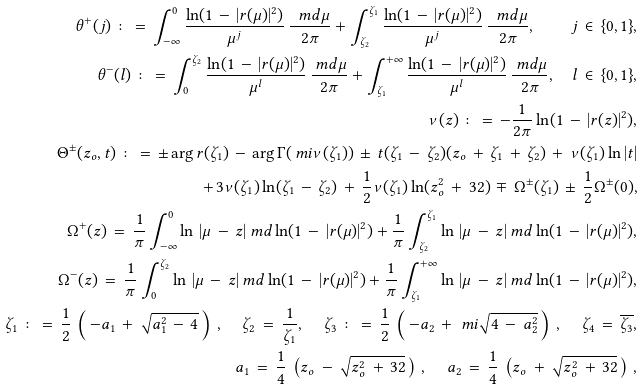Convert formula to latex. <formula><loc_0><loc_0><loc_500><loc_500>\theta ^ { + } ( j ) \, \colon = \, \int _ { - \infty } ^ { 0 } \frac { \ln ( 1 \, - \, | r ( \mu ) | ^ { 2 } ) } { \mu ^ { j } } \, \frac { \ m d \mu } { 2 \pi } + \int _ { \zeta _ { 2 } } ^ { \zeta _ { 1 } } \frac { \ln ( 1 \, - \, | r ( \mu ) | ^ { 2 } ) } { \mu ^ { j } } \, \frac { \ m d \mu } { 2 \pi } , \quad j \, \in \, \{ 0 , 1 \} , \\ \theta ^ { - } ( l ) \, \colon = \, \int _ { 0 } ^ { \zeta _ { 2 } } \frac { \ln ( 1 \, - \, | r ( \mu ) | ^ { 2 } ) } { \mu ^ { l } } \, \frac { \ m d \mu } { 2 \pi } + \int _ { \zeta _ { 1 } } ^ { + \infty } \frac { \ln ( 1 \, - \, | r ( \mu ) | ^ { 2 } ) } { \mu ^ { l } } \, \frac { \ m d \mu } { 2 \pi } , \quad l \, \in \, \{ 0 , 1 \} , \\ \nu ( z ) \, \colon = \, - \frac { 1 } { 2 \pi } \ln ( 1 \, - \, | r ( z ) | ^ { 2 } ) , \\ \Theta ^ { \pm } ( z _ { o } , t ) \, \colon = \, \pm \arg r ( \zeta _ { 1 } ) \, - \, \arg \Gamma ( \ m i \nu ( \zeta _ { 1 } ) ) \, \pm \, t ( \zeta _ { 1 } \, - \, \zeta _ { 2 } ) ( z _ { o } \, + \, \zeta _ { 1 } \, + \, \zeta _ { 2 } ) \, + \, \nu ( \zeta _ { 1 } ) \ln | t | \\ \quad + \, 3 \nu ( \zeta _ { 1 } ) \ln ( \zeta _ { 1 } \, - \, \zeta _ { 2 } ) \, + \, \frac { 1 } { 2 } \nu ( \zeta _ { 1 } ) \ln ( z _ { o } ^ { 2 } \, + \, 3 2 ) \, \mp \, \Omega ^ { \pm } ( \zeta _ { 1 } ) \, \pm \, \frac { 1 } { 2 } \Omega ^ { \pm } ( 0 ) , \\ \Omega ^ { + } ( z ) \, = \, \frac { 1 } { \pi } \int _ { - \infty } ^ { 0 } \ln \, | \mu \, - \, z | \ m d \ln ( 1 \, - \, | r ( \mu ) | ^ { 2 } ) + \frac { 1 } { \pi } \int _ { \zeta _ { 2 } } ^ { \zeta _ { 1 } } \ln \, | \mu \, - \, z | \ m d \ln ( 1 \, - \, | r ( \mu ) | ^ { 2 } ) , \\ \Omega ^ { - } ( z ) \, = \, \frac { 1 } { \pi } \int _ { 0 } ^ { \zeta _ { 2 } } \ln \, | \mu \, - \, z | \ m d \ln ( 1 \, - \, | r ( \mu ) | ^ { 2 } ) + \frac { 1 } { \pi } \int _ { \zeta _ { 1 } } ^ { + \infty } \ln \, | \mu \, - \, z | \ m d \ln ( 1 \, - \, | r ( \mu ) | ^ { 2 } ) , \\ \zeta _ { 1 } \, \colon = \, \frac { 1 } { 2 } \, \left ( \, - a _ { 1 } \, + \, \sqrt { a _ { 1 } ^ { 2 } \, - \, 4 } \, \right ) \, , \quad \, \zeta _ { 2 } \, = \, \frac { 1 } { \zeta _ { 1 } } , \quad \, \zeta _ { 3 } \, \colon = \, \frac { 1 } { 2 } \, \left ( \, - a _ { 2 } \, + \, \ m i \sqrt { 4 \, - \, a _ { 2 } ^ { 2 } } \, \right ) \, , \quad \, \zeta _ { 4 } \, = \, \overline { \zeta _ { 3 } } , \\ a _ { 1 } \, = \, \frac { 1 } { 4 } \, \left ( z _ { o } \, - \, \sqrt { z _ { o } ^ { 2 } \, + \, 3 2 } \, \right ) \, , \quad \, a _ { 2 } \, = \, \frac { 1 } { 4 } \, \left ( z _ { o } \, + \, \sqrt { z _ { o } ^ { 2 } \, + \, 3 2 } \, \right ) \, ,</formula> 